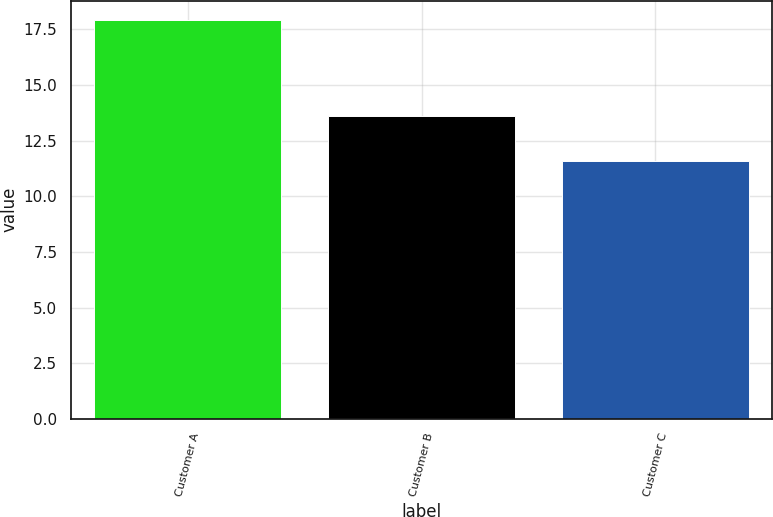Convert chart to OTSL. <chart><loc_0><loc_0><loc_500><loc_500><bar_chart><fcel>Customer A<fcel>Customer B<fcel>Customer C<nl><fcel>17.9<fcel>13.6<fcel>11.6<nl></chart> 